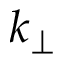<formula> <loc_0><loc_0><loc_500><loc_500>k _ { \perp }</formula> 